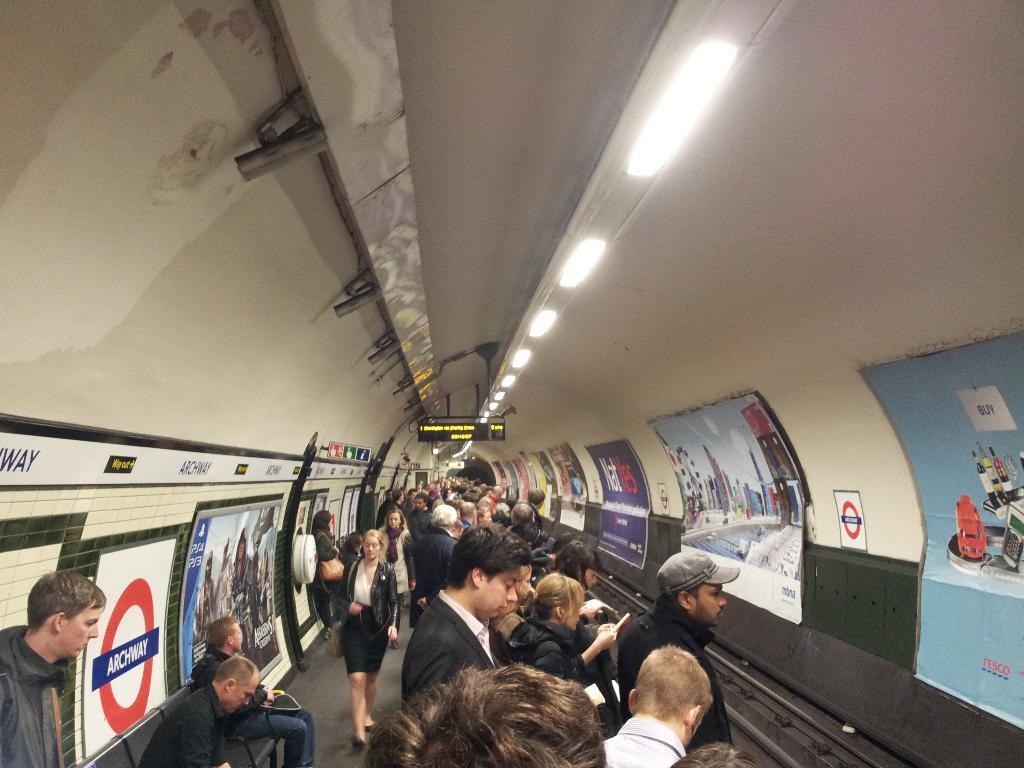Describe this image in one or two sentences. In this picture we can see people, posters, boards, mesh, and screen. Here we can see the lights. 